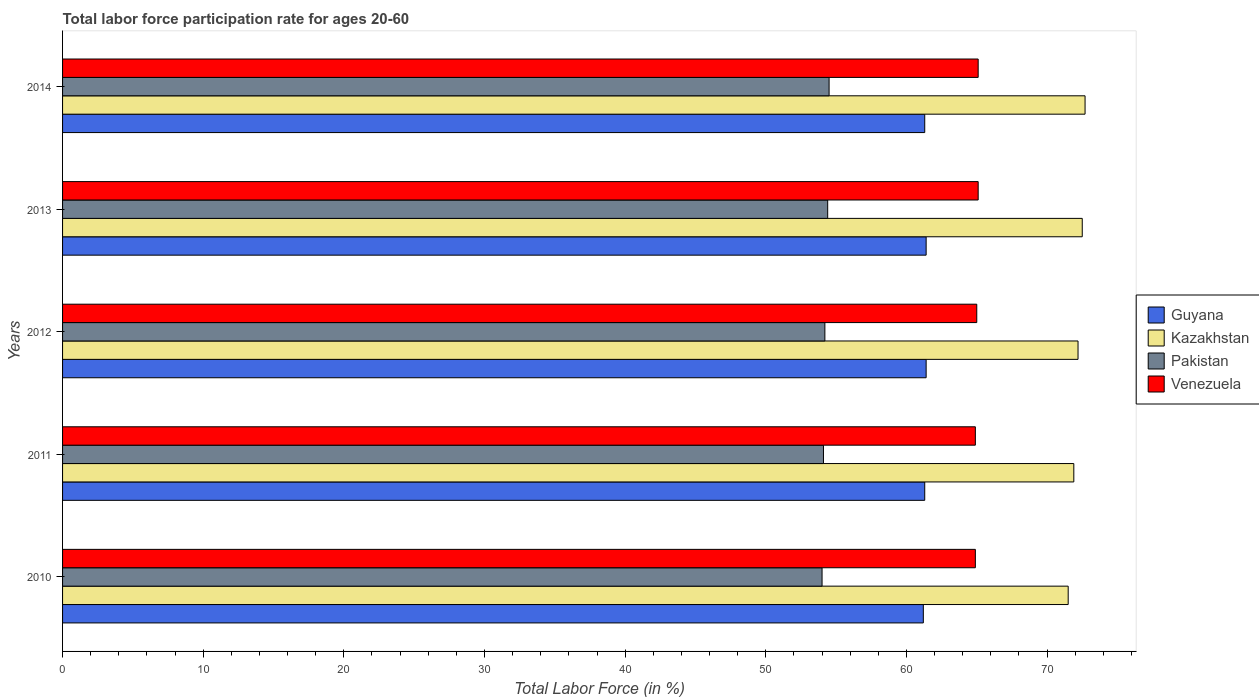How many different coloured bars are there?
Your answer should be very brief. 4. How many bars are there on the 2nd tick from the top?
Your answer should be very brief. 4. What is the labor force participation rate in Kazakhstan in 2011?
Ensure brevity in your answer.  71.9. Across all years, what is the maximum labor force participation rate in Pakistan?
Your answer should be very brief. 54.5. Across all years, what is the minimum labor force participation rate in Venezuela?
Give a very brief answer. 64.9. In which year was the labor force participation rate in Guyana minimum?
Make the answer very short. 2010. What is the total labor force participation rate in Venezuela in the graph?
Your answer should be very brief. 325. What is the difference between the labor force participation rate in Guyana in 2010 and that in 2014?
Your response must be concise. -0.1. What is the difference between the labor force participation rate in Kazakhstan in 2013 and the labor force participation rate in Guyana in 2012?
Provide a short and direct response. 11.1. What is the average labor force participation rate in Venezuela per year?
Give a very brief answer. 65. In the year 2011, what is the difference between the labor force participation rate in Pakistan and labor force participation rate in Venezuela?
Ensure brevity in your answer.  -10.8. Is the labor force participation rate in Venezuela in 2010 less than that in 2013?
Ensure brevity in your answer.  Yes. Is the difference between the labor force participation rate in Pakistan in 2012 and 2013 greater than the difference between the labor force participation rate in Venezuela in 2012 and 2013?
Offer a terse response. No. What is the difference between the highest and the second highest labor force participation rate in Kazakhstan?
Provide a short and direct response. 0.2. What is the difference between the highest and the lowest labor force participation rate in Venezuela?
Give a very brief answer. 0.2. In how many years, is the labor force participation rate in Kazakhstan greater than the average labor force participation rate in Kazakhstan taken over all years?
Your answer should be very brief. 3. Is it the case that in every year, the sum of the labor force participation rate in Pakistan and labor force participation rate in Kazakhstan is greater than the sum of labor force participation rate in Guyana and labor force participation rate in Venezuela?
Offer a terse response. No. What does the 3rd bar from the top in 2014 represents?
Make the answer very short. Kazakhstan. What does the 1st bar from the bottom in 2013 represents?
Your response must be concise. Guyana. Is it the case that in every year, the sum of the labor force participation rate in Pakistan and labor force participation rate in Venezuela is greater than the labor force participation rate in Guyana?
Ensure brevity in your answer.  Yes. Are all the bars in the graph horizontal?
Keep it short and to the point. Yes. What is the difference between two consecutive major ticks on the X-axis?
Make the answer very short. 10. Does the graph contain grids?
Offer a very short reply. No. Where does the legend appear in the graph?
Make the answer very short. Center right. How are the legend labels stacked?
Your answer should be compact. Vertical. What is the title of the graph?
Your response must be concise. Total labor force participation rate for ages 20-60. Does "OECD members" appear as one of the legend labels in the graph?
Give a very brief answer. No. What is the label or title of the X-axis?
Make the answer very short. Total Labor Force (in %). What is the Total Labor Force (in %) in Guyana in 2010?
Your answer should be very brief. 61.2. What is the Total Labor Force (in %) of Kazakhstan in 2010?
Give a very brief answer. 71.5. What is the Total Labor Force (in %) of Venezuela in 2010?
Your answer should be very brief. 64.9. What is the Total Labor Force (in %) in Guyana in 2011?
Make the answer very short. 61.3. What is the Total Labor Force (in %) of Kazakhstan in 2011?
Make the answer very short. 71.9. What is the Total Labor Force (in %) of Pakistan in 2011?
Your response must be concise. 54.1. What is the Total Labor Force (in %) in Venezuela in 2011?
Provide a succinct answer. 64.9. What is the Total Labor Force (in %) in Guyana in 2012?
Your answer should be very brief. 61.4. What is the Total Labor Force (in %) in Kazakhstan in 2012?
Your answer should be very brief. 72.2. What is the Total Labor Force (in %) in Pakistan in 2012?
Your answer should be very brief. 54.2. What is the Total Labor Force (in %) in Guyana in 2013?
Give a very brief answer. 61.4. What is the Total Labor Force (in %) in Kazakhstan in 2013?
Offer a very short reply. 72.5. What is the Total Labor Force (in %) of Pakistan in 2013?
Provide a succinct answer. 54.4. What is the Total Labor Force (in %) in Venezuela in 2013?
Your answer should be very brief. 65.1. What is the Total Labor Force (in %) in Guyana in 2014?
Give a very brief answer. 61.3. What is the Total Labor Force (in %) of Kazakhstan in 2014?
Provide a short and direct response. 72.7. What is the Total Labor Force (in %) of Pakistan in 2014?
Provide a succinct answer. 54.5. What is the Total Labor Force (in %) in Venezuela in 2014?
Give a very brief answer. 65.1. Across all years, what is the maximum Total Labor Force (in %) of Guyana?
Provide a succinct answer. 61.4. Across all years, what is the maximum Total Labor Force (in %) in Kazakhstan?
Give a very brief answer. 72.7. Across all years, what is the maximum Total Labor Force (in %) of Pakistan?
Your answer should be compact. 54.5. Across all years, what is the maximum Total Labor Force (in %) of Venezuela?
Your answer should be very brief. 65.1. Across all years, what is the minimum Total Labor Force (in %) of Guyana?
Give a very brief answer. 61.2. Across all years, what is the minimum Total Labor Force (in %) of Kazakhstan?
Keep it short and to the point. 71.5. Across all years, what is the minimum Total Labor Force (in %) in Pakistan?
Ensure brevity in your answer.  54. Across all years, what is the minimum Total Labor Force (in %) in Venezuela?
Provide a succinct answer. 64.9. What is the total Total Labor Force (in %) of Guyana in the graph?
Give a very brief answer. 306.6. What is the total Total Labor Force (in %) in Kazakhstan in the graph?
Give a very brief answer. 360.8. What is the total Total Labor Force (in %) of Pakistan in the graph?
Provide a short and direct response. 271.2. What is the total Total Labor Force (in %) in Venezuela in the graph?
Keep it short and to the point. 325. What is the difference between the Total Labor Force (in %) of Guyana in 2010 and that in 2011?
Your response must be concise. -0.1. What is the difference between the Total Labor Force (in %) of Kazakhstan in 2010 and that in 2011?
Provide a short and direct response. -0.4. What is the difference between the Total Labor Force (in %) of Pakistan in 2010 and that in 2011?
Ensure brevity in your answer.  -0.1. What is the difference between the Total Labor Force (in %) in Venezuela in 2010 and that in 2011?
Ensure brevity in your answer.  0. What is the difference between the Total Labor Force (in %) of Kazakhstan in 2010 and that in 2012?
Offer a terse response. -0.7. What is the difference between the Total Labor Force (in %) in Venezuela in 2010 and that in 2012?
Offer a terse response. -0.1. What is the difference between the Total Labor Force (in %) of Kazakhstan in 2010 and that in 2013?
Make the answer very short. -1. What is the difference between the Total Labor Force (in %) of Pakistan in 2010 and that in 2013?
Provide a succinct answer. -0.4. What is the difference between the Total Labor Force (in %) of Venezuela in 2010 and that in 2013?
Provide a short and direct response. -0.2. What is the difference between the Total Labor Force (in %) in Guyana in 2010 and that in 2014?
Keep it short and to the point. -0.1. What is the difference between the Total Labor Force (in %) in Pakistan in 2010 and that in 2014?
Offer a very short reply. -0.5. What is the difference between the Total Labor Force (in %) of Kazakhstan in 2011 and that in 2012?
Provide a short and direct response. -0.3. What is the difference between the Total Labor Force (in %) in Pakistan in 2011 and that in 2012?
Provide a succinct answer. -0.1. What is the difference between the Total Labor Force (in %) in Venezuela in 2011 and that in 2012?
Your response must be concise. -0.1. What is the difference between the Total Labor Force (in %) of Guyana in 2011 and that in 2013?
Keep it short and to the point. -0.1. What is the difference between the Total Labor Force (in %) of Pakistan in 2011 and that in 2013?
Your response must be concise. -0.3. What is the difference between the Total Labor Force (in %) in Pakistan in 2011 and that in 2014?
Make the answer very short. -0.4. What is the difference between the Total Labor Force (in %) in Venezuela in 2011 and that in 2014?
Make the answer very short. -0.2. What is the difference between the Total Labor Force (in %) in Guyana in 2012 and that in 2013?
Your response must be concise. 0. What is the difference between the Total Labor Force (in %) in Kazakhstan in 2012 and that in 2013?
Provide a short and direct response. -0.3. What is the difference between the Total Labor Force (in %) in Pakistan in 2012 and that in 2013?
Give a very brief answer. -0.2. What is the difference between the Total Labor Force (in %) in Venezuela in 2012 and that in 2013?
Give a very brief answer. -0.1. What is the difference between the Total Labor Force (in %) of Guyana in 2012 and that in 2014?
Ensure brevity in your answer.  0.1. What is the difference between the Total Labor Force (in %) in Kazakhstan in 2012 and that in 2014?
Provide a succinct answer. -0.5. What is the difference between the Total Labor Force (in %) in Venezuela in 2012 and that in 2014?
Keep it short and to the point. -0.1. What is the difference between the Total Labor Force (in %) of Kazakhstan in 2013 and that in 2014?
Ensure brevity in your answer.  -0.2. What is the difference between the Total Labor Force (in %) in Guyana in 2010 and the Total Labor Force (in %) in Venezuela in 2011?
Provide a short and direct response. -3.7. What is the difference between the Total Labor Force (in %) of Guyana in 2010 and the Total Labor Force (in %) of Kazakhstan in 2012?
Offer a very short reply. -11. What is the difference between the Total Labor Force (in %) in Guyana in 2010 and the Total Labor Force (in %) in Pakistan in 2012?
Your answer should be compact. 7. What is the difference between the Total Labor Force (in %) in Guyana in 2010 and the Total Labor Force (in %) in Venezuela in 2012?
Offer a very short reply. -3.8. What is the difference between the Total Labor Force (in %) of Kazakhstan in 2010 and the Total Labor Force (in %) of Pakistan in 2012?
Offer a very short reply. 17.3. What is the difference between the Total Labor Force (in %) in Kazakhstan in 2010 and the Total Labor Force (in %) in Venezuela in 2012?
Offer a very short reply. 6.5. What is the difference between the Total Labor Force (in %) of Pakistan in 2010 and the Total Labor Force (in %) of Venezuela in 2012?
Your answer should be compact. -11. What is the difference between the Total Labor Force (in %) in Guyana in 2010 and the Total Labor Force (in %) in Kazakhstan in 2013?
Provide a short and direct response. -11.3. What is the difference between the Total Labor Force (in %) in Kazakhstan in 2010 and the Total Labor Force (in %) in Pakistan in 2013?
Offer a terse response. 17.1. What is the difference between the Total Labor Force (in %) of Guyana in 2010 and the Total Labor Force (in %) of Kazakhstan in 2014?
Ensure brevity in your answer.  -11.5. What is the difference between the Total Labor Force (in %) of Guyana in 2010 and the Total Labor Force (in %) of Pakistan in 2014?
Your answer should be very brief. 6.7. What is the difference between the Total Labor Force (in %) of Kazakhstan in 2010 and the Total Labor Force (in %) of Venezuela in 2014?
Your answer should be compact. 6.4. What is the difference between the Total Labor Force (in %) of Pakistan in 2011 and the Total Labor Force (in %) of Venezuela in 2012?
Offer a very short reply. -10.9. What is the difference between the Total Labor Force (in %) of Guyana in 2011 and the Total Labor Force (in %) of Kazakhstan in 2014?
Ensure brevity in your answer.  -11.4. What is the difference between the Total Labor Force (in %) of Guyana in 2011 and the Total Labor Force (in %) of Pakistan in 2014?
Offer a very short reply. 6.8. What is the difference between the Total Labor Force (in %) of Kazakhstan in 2011 and the Total Labor Force (in %) of Venezuela in 2014?
Provide a short and direct response. 6.8. What is the difference between the Total Labor Force (in %) of Kazakhstan in 2012 and the Total Labor Force (in %) of Pakistan in 2013?
Provide a succinct answer. 17.8. What is the difference between the Total Labor Force (in %) in Guyana in 2012 and the Total Labor Force (in %) in Kazakhstan in 2014?
Offer a very short reply. -11.3. What is the difference between the Total Labor Force (in %) of Guyana in 2012 and the Total Labor Force (in %) of Pakistan in 2014?
Provide a short and direct response. 6.9. What is the difference between the Total Labor Force (in %) of Guyana in 2012 and the Total Labor Force (in %) of Venezuela in 2014?
Offer a very short reply. -3.7. What is the difference between the Total Labor Force (in %) in Kazakhstan in 2012 and the Total Labor Force (in %) in Pakistan in 2014?
Provide a succinct answer. 17.7. What is the difference between the Total Labor Force (in %) in Kazakhstan in 2012 and the Total Labor Force (in %) in Venezuela in 2014?
Your response must be concise. 7.1. What is the difference between the Total Labor Force (in %) of Guyana in 2013 and the Total Labor Force (in %) of Pakistan in 2014?
Offer a very short reply. 6.9. What is the difference between the Total Labor Force (in %) of Kazakhstan in 2013 and the Total Labor Force (in %) of Pakistan in 2014?
Give a very brief answer. 18. What is the difference between the Total Labor Force (in %) of Kazakhstan in 2013 and the Total Labor Force (in %) of Venezuela in 2014?
Your response must be concise. 7.4. What is the difference between the Total Labor Force (in %) of Pakistan in 2013 and the Total Labor Force (in %) of Venezuela in 2014?
Keep it short and to the point. -10.7. What is the average Total Labor Force (in %) of Guyana per year?
Give a very brief answer. 61.32. What is the average Total Labor Force (in %) of Kazakhstan per year?
Offer a terse response. 72.16. What is the average Total Labor Force (in %) of Pakistan per year?
Give a very brief answer. 54.24. In the year 2010, what is the difference between the Total Labor Force (in %) of Guyana and Total Labor Force (in %) of Pakistan?
Keep it short and to the point. 7.2. In the year 2010, what is the difference between the Total Labor Force (in %) in Guyana and Total Labor Force (in %) in Venezuela?
Make the answer very short. -3.7. In the year 2010, what is the difference between the Total Labor Force (in %) of Kazakhstan and Total Labor Force (in %) of Venezuela?
Offer a terse response. 6.6. In the year 2011, what is the difference between the Total Labor Force (in %) of Kazakhstan and Total Labor Force (in %) of Pakistan?
Your response must be concise. 17.8. In the year 2011, what is the difference between the Total Labor Force (in %) of Pakistan and Total Labor Force (in %) of Venezuela?
Your answer should be compact. -10.8. In the year 2012, what is the difference between the Total Labor Force (in %) in Guyana and Total Labor Force (in %) in Kazakhstan?
Offer a terse response. -10.8. In the year 2012, what is the difference between the Total Labor Force (in %) of Guyana and Total Labor Force (in %) of Pakistan?
Offer a terse response. 7.2. In the year 2012, what is the difference between the Total Labor Force (in %) in Guyana and Total Labor Force (in %) in Venezuela?
Provide a short and direct response. -3.6. In the year 2012, what is the difference between the Total Labor Force (in %) of Kazakhstan and Total Labor Force (in %) of Venezuela?
Your answer should be very brief. 7.2. In the year 2012, what is the difference between the Total Labor Force (in %) in Pakistan and Total Labor Force (in %) in Venezuela?
Provide a short and direct response. -10.8. In the year 2013, what is the difference between the Total Labor Force (in %) of Kazakhstan and Total Labor Force (in %) of Venezuela?
Your response must be concise. 7.4. In the year 2013, what is the difference between the Total Labor Force (in %) in Pakistan and Total Labor Force (in %) in Venezuela?
Provide a short and direct response. -10.7. In the year 2014, what is the difference between the Total Labor Force (in %) in Guyana and Total Labor Force (in %) in Kazakhstan?
Ensure brevity in your answer.  -11.4. What is the ratio of the Total Labor Force (in %) in Guyana in 2010 to that in 2011?
Provide a succinct answer. 1. What is the ratio of the Total Labor Force (in %) of Pakistan in 2010 to that in 2011?
Ensure brevity in your answer.  1. What is the ratio of the Total Labor Force (in %) of Venezuela in 2010 to that in 2011?
Provide a succinct answer. 1. What is the ratio of the Total Labor Force (in %) of Guyana in 2010 to that in 2012?
Give a very brief answer. 1. What is the ratio of the Total Labor Force (in %) of Kazakhstan in 2010 to that in 2012?
Your answer should be very brief. 0.99. What is the ratio of the Total Labor Force (in %) in Pakistan in 2010 to that in 2012?
Offer a very short reply. 1. What is the ratio of the Total Labor Force (in %) of Venezuela in 2010 to that in 2012?
Your response must be concise. 1. What is the ratio of the Total Labor Force (in %) in Kazakhstan in 2010 to that in 2013?
Your answer should be compact. 0.99. What is the ratio of the Total Labor Force (in %) in Pakistan in 2010 to that in 2013?
Keep it short and to the point. 0.99. What is the ratio of the Total Labor Force (in %) in Guyana in 2010 to that in 2014?
Offer a terse response. 1. What is the ratio of the Total Labor Force (in %) in Kazakhstan in 2010 to that in 2014?
Your response must be concise. 0.98. What is the ratio of the Total Labor Force (in %) of Pakistan in 2010 to that in 2014?
Your answer should be very brief. 0.99. What is the ratio of the Total Labor Force (in %) in Venezuela in 2010 to that in 2014?
Your response must be concise. 1. What is the ratio of the Total Labor Force (in %) in Pakistan in 2011 to that in 2012?
Ensure brevity in your answer.  1. What is the ratio of the Total Labor Force (in %) of Venezuela in 2011 to that in 2012?
Keep it short and to the point. 1. What is the ratio of the Total Labor Force (in %) of Kazakhstan in 2011 to that in 2014?
Give a very brief answer. 0.99. What is the ratio of the Total Labor Force (in %) of Pakistan in 2011 to that in 2014?
Offer a terse response. 0.99. What is the ratio of the Total Labor Force (in %) of Venezuela in 2011 to that in 2014?
Your answer should be compact. 1. What is the ratio of the Total Labor Force (in %) in Venezuela in 2012 to that in 2013?
Your answer should be compact. 1. What is the ratio of the Total Labor Force (in %) in Guyana in 2012 to that in 2014?
Ensure brevity in your answer.  1. What is the ratio of the Total Labor Force (in %) of Kazakhstan in 2012 to that in 2014?
Provide a short and direct response. 0.99. What is the ratio of the Total Labor Force (in %) in Pakistan in 2012 to that in 2014?
Keep it short and to the point. 0.99. What is the ratio of the Total Labor Force (in %) in Venezuela in 2012 to that in 2014?
Ensure brevity in your answer.  1. What is the ratio of the Total Labor Force (in %) in Kazakhstan in 2013 to that in 2014?
Keep it short and to the point. 1. What is the ratio of the Total Labor Force (in %) in Pakistan in 2013 to that in 2014?
Your answer should be very brief. 1. What is the ratio of the Total Labor Force (in %) of Venezuela in 2013 to that in 2014?
Your response must be concise. 1. What is the difference between the highest and the second highest Total Labor Force (in %) of Pakistan?
Ensure brevity in your answer.  0.1. What is the difference between the highest and the lowest Total Labor Force (in %) of Guyana?
Offer a terse response. 0.2. What is the difference between the highest and the lowest Total Labor Force (in %) of Kazakhstan?
Provide a succinct answer. 1.2. What is the difference between the highest and the lowest Total Labor Force (in %) in Pakistan?
Give a very brief answer. 0.5. What is the difference between the highest and the lowest Total Labor Force (in %) of Venezuela?
Your response must be concise. 0.2. 